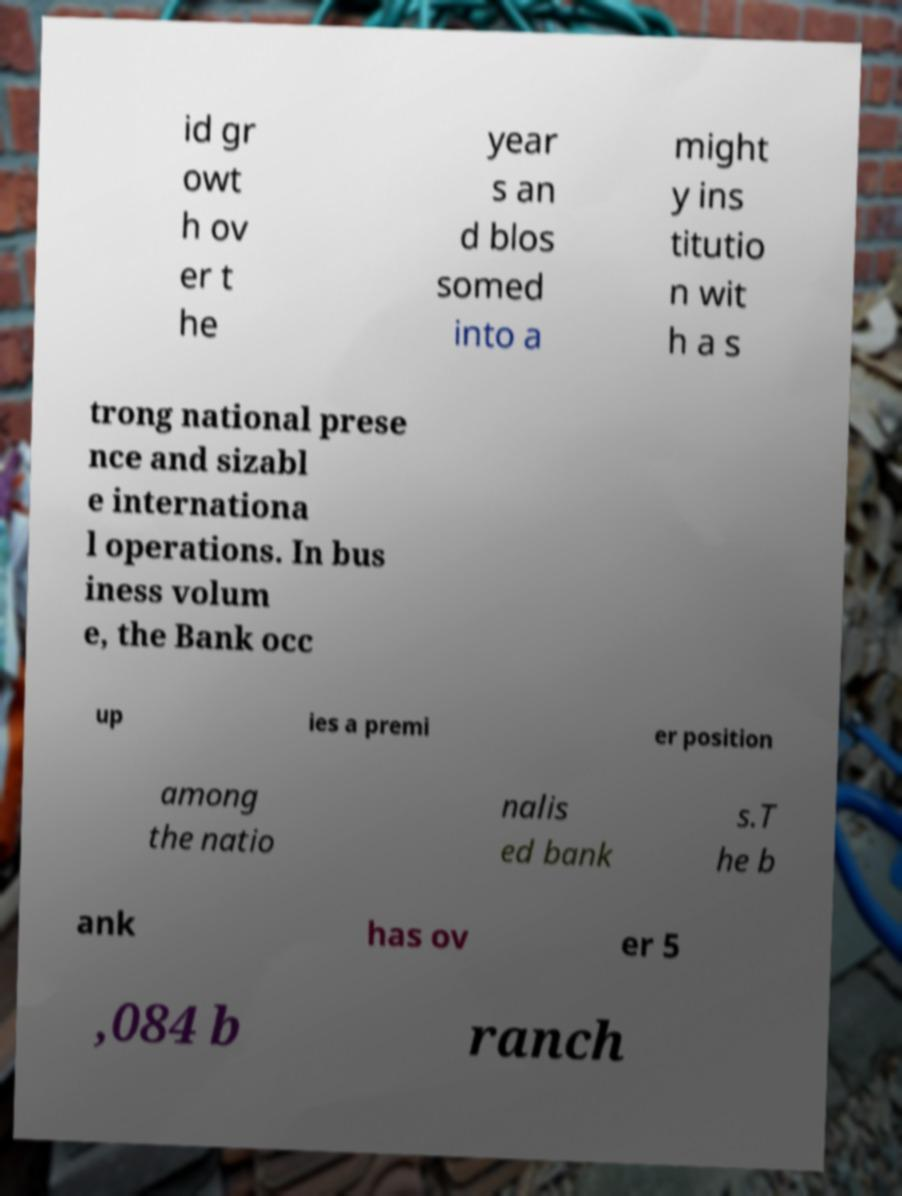I need the written content from this picture converted into text. Can you do that? id gr owt h ov er t he year s an d blos somed into a might y ins titutio n wit h a s trong national prese nce and sizabl e internationa l operations. In bus iness volum e, the Bank occ up ies a premi er position among the natio nalis ed bank s.T he b ank has ov er 5 ,084 b ranch 